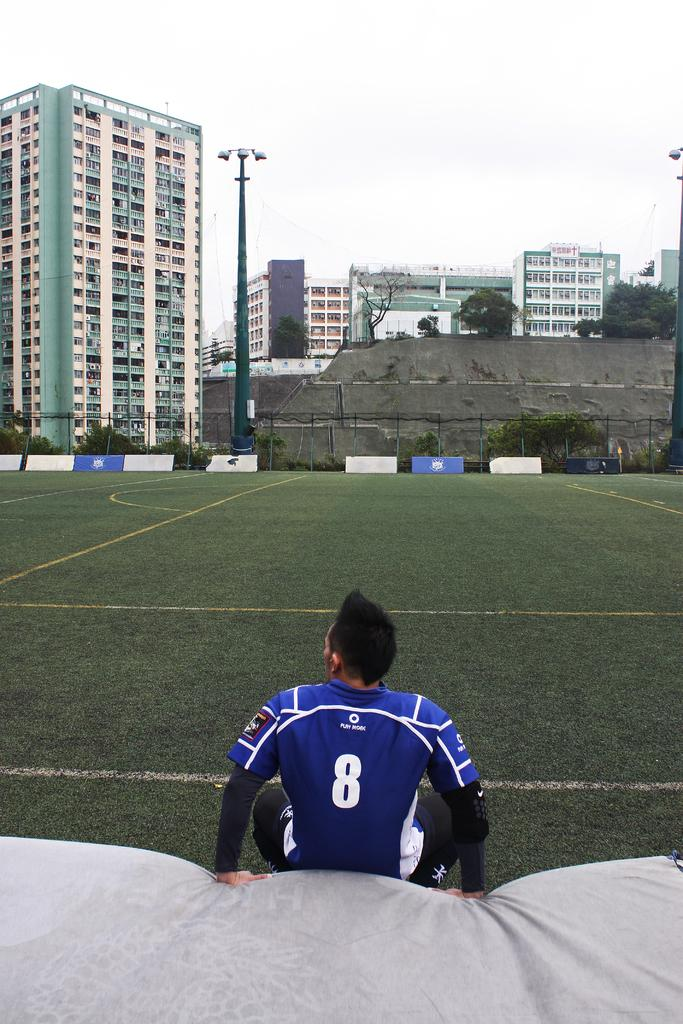What type of structures can be seen in the image? There are buildings in the image. What architectural features are present on the buildings? There are windows visible on the buildings. What type of vegetation is present in the image? There are trees in the image. What type of barrier can be seen in the image? There is fencing in the image. What type of material is present in the image? There are boards in the image. What is visible in the background of the image? The sky is visible in the image. Can you describe the person in the image? There is one person in front in the image. What type of trail does the person in the image desire to follow? There is no information about the person's desires or a trail in the image. What nation is represented by the buildings in the image? The image does not provide any information about the nation associated with the buildings. 